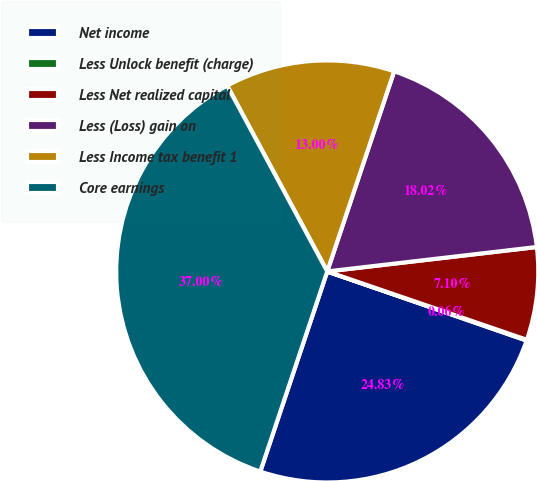Convert chart. <chart><loc_0><loc_0><loc_500><loc_500><pie_chart><fcel>Net income<fcel>Less Unlock benefit (charge)<fcel>Less Net realized capital<fcel>Less (Loss) gain on<fcel>Less Income tax benefit 1<fcel>Core earnings<nl><fcel>24.83%<fcel>0.06%<fcel>7.1%<fcel>18.02%<fcel>13.0%<fcel>37.0%<nl></chart> 